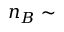<formula> <loc_0><loc_0><loc_500><loc_500>n _ { B } \sim</formula> 